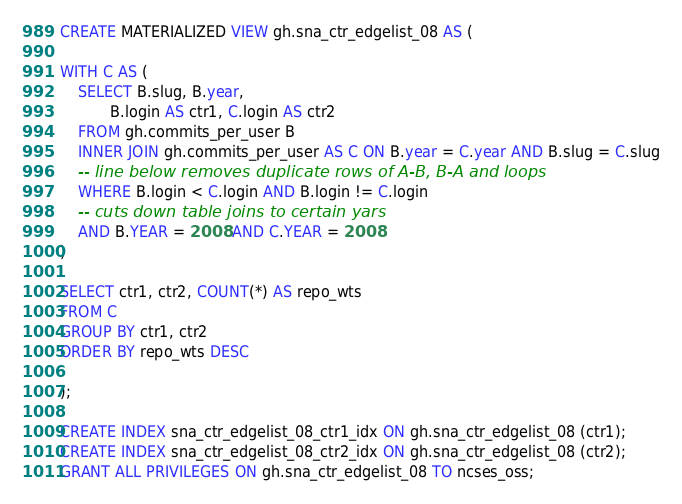Convert code to text. <code><loc_0><loc_0><loc_500><loc_500><_SQL_>
CREATE MATERIALIZED VIEW gh.sna_ctr_edgelist_08 AS (

WITH C AS (
	SELECT B.slug, B.year,
           B.login AS ctr1, C.login AS ctr2
	FROM gh.commits_per_user B
	INNER JOIN gh.commits_per_user AS C ON B.year = C.year AND B.slug = C.slug
	-- line below removes duplicate rows of A-B, B-A and loops
	WHERE B.login < C.login AND B.login != C.login
	-- cuts down table joins to certain yars
	AND B.YEAR = 2008 AND C.YEAR = 2008
)

SELECT ctr1, ctr2, COUNT(*) AS repo_wts
FROM C
GROUP BY ctr1, ctr2
ORDER BY repo_wts DESC

);

CREATE INDEX sna_ctr_edgelist_08_ctr1_idx ON gh.sna_ctr_edgelist_08 (ctr1);
CREATE INDEX sna_ctr_edgelist_08_ctr2_idx ON gh.sna_ctr_edgelist_08 (ctr2);
GRANT ALL PRIVILEGES ON gh.sna_ctr_edgelist_08 TO ncses_oss;

</code> 